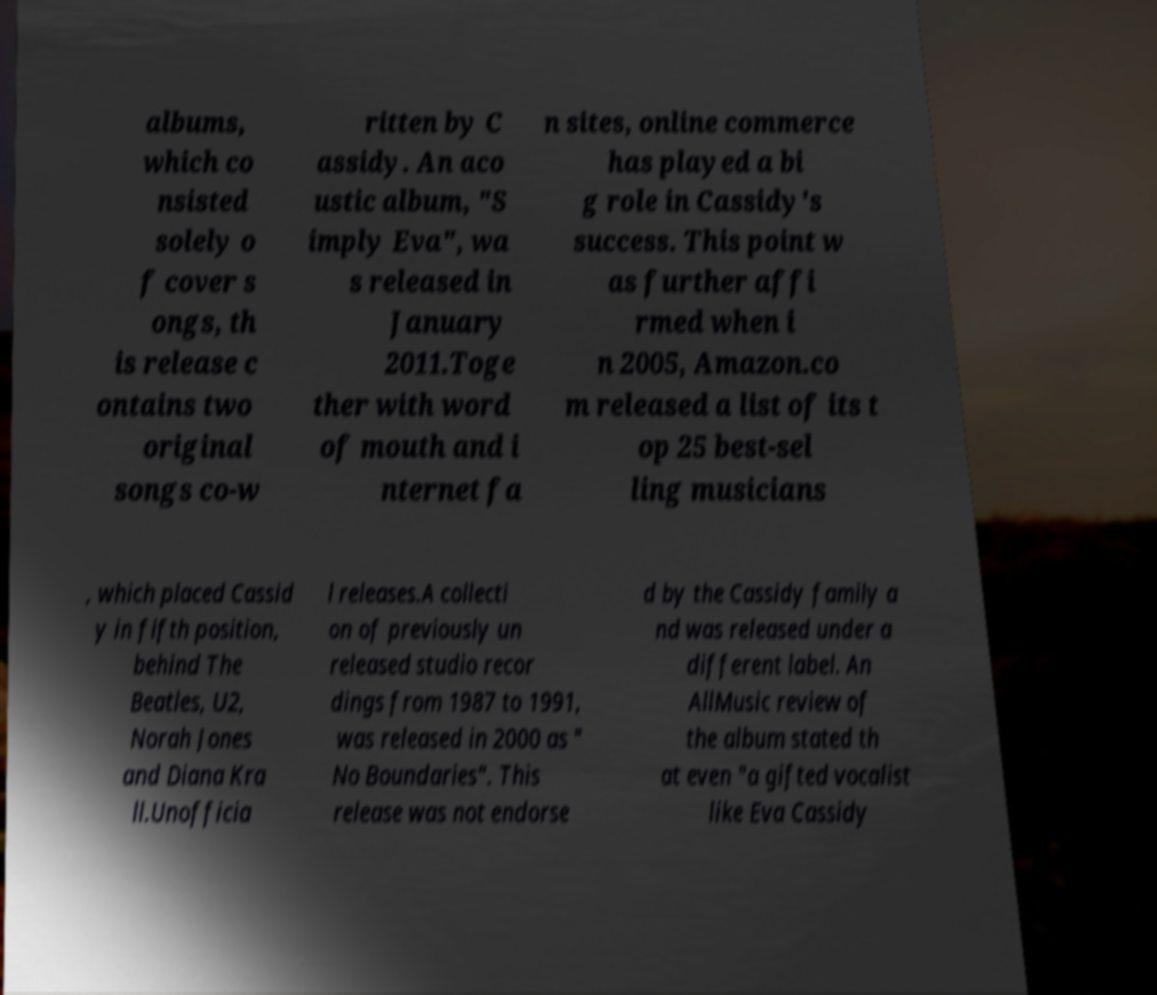There's text embedded in this image that I need extracted. Can you transcribe it verbatim? albums, which co nsisted solely o f cover s ongs, th is release c ontains two original songs co-w ritten by C assidy. An aco ustic album, "S imply Eva", wa s released in January 2011.Toge ther with word of mouth and i nternet fa n sites, online commerce has played a bi g role in Cassidy's success. This point w as further affi rmed when i n 2005, Amazon.co m released a list of its t op 25 best-sel ling musicians , which placed Cassid y in fifth position, behind The Beatles, U2, Norah Jones and Diana Kra ll.Unofficia l releases.A collecti on of previously un released studio recor dings from 1987 to 1991, was released in 2000 as " No Boundaries". This release was not endorse d by the Cassidy family a nd was released under a different label. An AllMusic review of the album stated th at even "a gifted vocalist like Eva Cassidy 